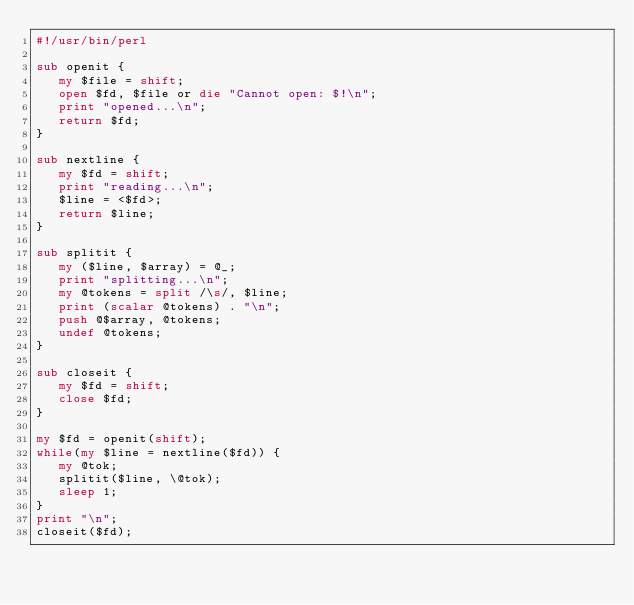Convert code to text. <code><loc_0><loc_0><loc_500><loc_500><_Perl_>#!/usr/bin/perl

sub openit {
   my $file = shift;
   open $fd, $file or die "Cannot open: $!\n";
   print "opened...\n";
   return $fd;
}

sub nextline {
   my $fd = shift;
   print "reading...\n";
   $line = <$fd>;
   return $line;
}

sub splitit {
   my ($line, $array) = @_;
   print "splitting...\n";
   my @tokens = split /\s/, $line;
   print (scalar @tokens) . "\n";
   push @$array, @tokens;
   undef @tokens;
}

sub closeit {
   my $fd = shift;
   close $fd;
}

my $fd = openit(shift);
while(my $line = nextline($fd)) {
   my @tok;
   splitit($line, \@tok);
   sleep 1;
}
print "\n";
closeit($fd);
</code> 